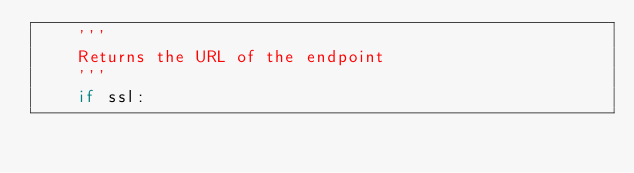<code> <loc_0><loc_0><loc_500><loc_500><_Python_>    '''
    Returns the URL of the endpoint
    '''
    if ssl:</code> 